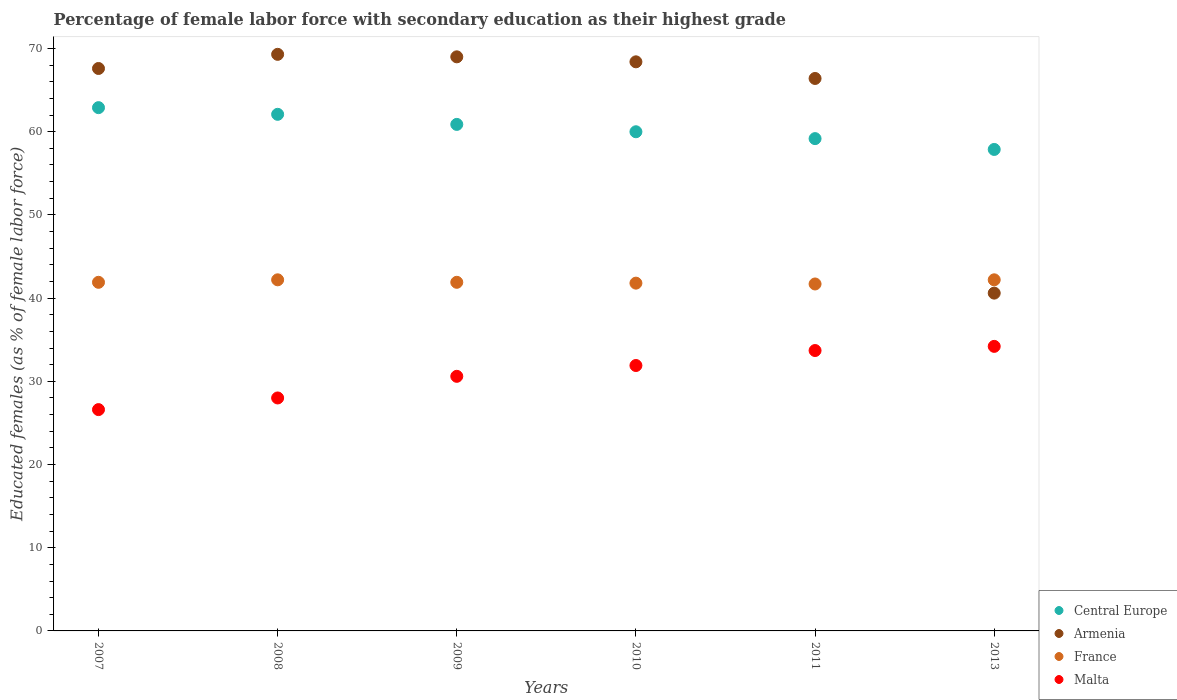Is the number of dotlines equal to the number of legend labels?
Your response must be concise. Yes. What is the percentage of female labor force with secondary education in Armenia in 2008?
Offer a very short reply. 69.3. Across all years, what is the maximum percentage of female labor force with secondary education in France?
Offer a terse response. 42.2. Across all years, what is the minimum percentage of female labor force with secondary education in France?
Make the answer very short. 41.7. In which year was the percentage of female labor force with secondary education in Armenia minimum?
Provide a short and direct response. 2013. What is the total percentage of female labor force with secondary education in Central Europe in the graph?
Your answer should be compact. 362.9. What is the difference between the percentage of female labor force with secondary education in France in 2010 and that in 2011?
Provide a short and direct response. 0.1. What is the difference between the percentage of female labor force with secondary education in Central Europe in 2008 and the percentage of female labor force with secondary education in Malta in 2009?
Offer a terse response. 31.49. What is the average percentage of female labor force with secondary education in Central Europe per year?
Provide a succinct answer. 60.48. In how many years, is the percentage of female labor force with secondary education in Armenia greater than 26 %?
Your answer should be compact. 6. What is the ratio of the percentage of female labor force with secondary education in Armenia in 2007 to that in 2010?
Give a very brief answer. 0.99. Is the difference between the percentage of female labor force with secondary education in France in 2011 and 2013 greater than the difference between the percentage of female labor force with secondary education in Malta in 2011 and 2013?
Offer a terse response. No. What is the difference between the highest and the second highest percentage of female labor force with secondary education in Malta?
Give a very brief answer. 0.5. What is the difference between the highest and the lowest percentage of female labor force with secondary education in Malta?
Your answer should be compact. 7.6. Is it the case that in every year, the sum of the percentage of female labor force with secondary education in France and percentage of female labor force with secondary education in Central Europe  is greater than the sum of percentage of female labor force with secondary education in Armenia and percentage of female labor force with secondary education in Malta?
Your answer should be very brief. Yes. Is it the case that in every year, the sum of the percentage of female labor force with secondary education in Central Europe and percentage of female labor force with secondary education in France  is greater than the percentage of female labor force with secondary education in Malta?
Keep it short and to the point. Yes. How many years are there in the graph?
Your answer should be very brief. 6. Does the graph contain grids?
Keep it short and to the point. No. Where does the legend appear in the graph?
Your answer should be compact. Bottom right. What is the title of the graph?
Your answer should be compact. Percentage of female labor force with secondary education as their highest grade. Does "High income" appear as one of the legend labels in the graph?
Your answer should be very brief. No. What is the label or title of the Y-axis?
Your answer should be very brief. Educated females (as % of female labor force). What is the Educated females (as % of female labor force) of Central Europe in 2007?
Your response must be concise. 62.89. What is the Educated females (as % of female labor force) of Armenia in 2007?
Keep it short and to the point. 67.6. What is the Educated females (as % of female labor force) of France in 2007?
Ensure brevity in your answer.  41.9. What is the Educated females (as % of female labor force) in Malta in 2007?
Offer a terse response. 26.6. What is the Educated females (as % of female labor force) in Central Europe in 2008?
Your answer should be very brief. 62.09. What is the Educated females (as % of female labor force) in Armenia in 2008?
Make the answer very short. 69.3. What is the Educated females (as % of female labor force) of France in 2008?
Provide a short and direct response. 42.2. What is the Educated females (as % of female labor force) of Central Europe in 2009?
Keep it short and to the point. 60.88. What is the Educated females (as % of female labor force) of Armenia in 2009?
Provide a short and direct response. 69. What is the Educated females (as % of female labor force) in France in 2009?
Provide a succinct answer. 41.9. What is the Educated females (as % of female labor force) in Malta in 2009?
Ensure brevity in your answer.  30.6. What is the Educated females (as % of female labor force) of Central Europe in 2010?
Provide a succinct answer. 59.99. What is the Educated females (as % of female labor force) in Armenia in 2010?
Provide a short and direct response. 68.4. What is the Educated females (as % of female labor force) of France in 2010?
Provide a short and direct response. 41.8. What is the Educated females (as % of female labor force) in Malta in 2010?
Your answer should be very brief. 31.9. What is the Educated females (as % of female labor force) in Central Europe in 2011?
Make the answer very short. 59.17. What is the Educated females (as % of female labor force) in Armenia in 2011?
Give a very brief answer. 66.4. What is the Educated females (as % of female labor force) in France in 2011?
Provide a short and direct response. 41.7. What is the Educated females (as % of female labor force) of Malta in 2011?
Keep it short and to the point. 33.7. What is the Educated females (as % of female labor force) in Central Europe in 2013?
Offer a very short reply. 57.87. What is the Educated females (as % of female labor force) in Armenia in 2013?
Ensure brevity in your answer.  40.6. What is the Educated females (as % of female labor force) of France in 2013?
Provide a short and direct response. 42.2. What is the Educated females (as % of female labor force) in Malta in 2013?
Provide a short and direct response. 34.2. Across all years, what is the maximum Educated females (as % of female labor force) of Central Europe?
Your answer should be compact. 62.89. Across all years, what is the maximum Educated females (as % of female labor force) in Armenia?
Offer a very short reply. 69.3. Across all years, what is the maximum Educated females (as % of female labor force) in France?
Provide a short and direct response. 42.2. Across all years, what is the maximum Educated females (as % of female labor force) in Malta?
Keep it short and to the point. 34.2. Across all years, what is the minimum Educated females (as % of female labor force) of Central Europe?
Provide a succinct answer. 57.87. Across all years, what is the minimum Educated females (as % of female labor force) in Armenia?
Provide a short and direct response. 40.6. Across all years, what is the minimum Educated females (as % of female labor force) of France?
Offer a terse response. 41.7. Across all years, what is the minimum Educated females (as % of female labor force) in Malta?
Give a very brief answer. 26.6. What is the total Educated females (as % of female labor force) in Central Europe in the graph?
Keep it short and to the point. 362.9. What is the total Educated females (as % of female labor force) of Armenia in the graph?
Offer a terse response. 381.3. What is the total Educated females (as % of female labor force) of France in the graph?
Offer a very short reply. 251.7. What is the total Educated females (as % of female labor force) in Malta in the graph?
Your response must be concise. 185. What is the difference between the Educated females (as % of female labor force) in Central Europe in 2007 and that in 2008?
Ensure brevity in your answer.  0.8. What is the difference between the Educated females (as % of female labor force) in France in 2007 and that in 2008?
Your answer should be very brief. -0.3. What is the difference between the Educated females (as % of female labor force) of Central Europe in 2007 and that in 2009?
Provide a short and direct response. 2.01. What is the difference between the Educated females (as % of female labor force) in France in 2007 and that in 2009?
Give a very brief answer. 0. What is the difference between the Educated females (as % of female labor force) of Central Europe in 2007 and that in 2010?
Your answer should be very brief. 2.9. What is the difference between the Educated females (as % of female labor force) in Central Europe in 2007 and that in 2011?
Provide a short and direct response. 3.72. What is the difference between the Educated females (as % of female labor force) of Armenia in 2007 and that in 2011?
Your response must be concise. 1.2. What is the difference between the Educated females (as % of female labor force) in France in 2007 and that in 2011?
Provide a succinct answer. 0.2. What is the difference between the Educated females (as % of female labor force) of Malta in 2007 and that in 2011?
Make the answer very short. -7.1. What is the difference between the Educated females (as % of female labor force) in Central Europe in 2007 and that in 2013?
Your answer should be compact. 5.02. What is the difference between the Educated females (as % of female labor force) of Armenia in 2007 and that in 2013?
Your answer should be very brief. 27. What is the difference between the Educated females (as % of female labor force) of Central Europe in 2008 and that in 2009?
Your response must be concise. 1.21. What is the difference between the Educated females (as % of female labor force) of Armenia in 2008 and that in 2009?
Keep it short and to the point. 0.3. What is the difference between the Educated females (as % of female labor force) of Malta in 2008 and that in 2009?
Make the answer very short. -2.6. What is the difference between the Educated females (as % of female labor force) of Central Europe in 2008 and that in 2010?
Keep it short and to the point. 2.1. What is the difference between the Educated females (as % of female labor force) in France in 2008 and that in 2010?
Provide a succinct answer. 0.4. What is the difference between the Educated females (as % of female labor force) in Central Europe in 2008 and that in 2011?
Give a very brief answer. 2.92. What is the difference between the Educated females (as % of female labor force) in Armenia in 2008 and that in 2011?
Your answer should be very brief. 2.9. What is the difference between the Educated females (as % of female labor force) in France in 2008 and that in 2011?
Give a very brief answer. 0.5. What is the difference between the Educated females (as % of female labor force) in Central Europe in 2008 and that in 2013?
Your response must be concise. 4.22. What is the difference between the Educated females (as % of female labor force) in Armenia in 2008 and that in 2013?
Offer a very short reply. 28.7. What is the difference between the Educated females (as % of female labor force) in France in 2008 and that in 2013?
Your answer should be very brief. 0. What is the difference between the Educated females (as % of female labor force) in Central Europe in 2009 and that in 2010?
Keep it short and to the point. 0.88. What is the difference between the Educated females (as % of female labor force) in France in 2009 and that in 2010?
Keep it short and to the point. 0.1. What is the difference between the Educated females (as % of female labor force) of Malta in 2009 and that in 2010?
Provide a short and direct response. -1.3. What is the difference between the Educated females (as % of female labor force) of Central Europe in 2009 and that in 2011?
Your answer should be compact. 1.71. What is the difference between the Educated females (as % of female labor force) in Armenia in 2009 and that in 2011?
Ensure brevity in your answer.  2.6. What is the difference between the Educated females (as % of female labor force) of Central Europe in 2009 and that in 2013?
Keep it short and to the point. 3.01. What is the difference between the Educated females (as % of female labor force) in Armenia in 2009 and that in 2013?
Offer a terse response. 28.4. What is the difference between the Educated females (as % of female labor force) in Central Europe in 2010 and that in 2011?
Offer a very short reply. 0.82. What is the difference between the Educated females (as % of female labor force) of Armenia in 2010 and that in 2011?
Your response must be concise. 2. What is the difference between the Educated females (as % of female labor force) of Malta in 2010 and that in 2011?
Provide a short and direct response. -1.8. What is the difference between the Educated females (as % of female labor force) in Central Europe in 2010 and that in 2013?
Give a very brief answer. 2.13. What is the difference between the Educated females (as % of female labor force) of Armenia in 2010 and that in 2013?
Offer a very short reply. 27.8. What is the difference between the Educated females (as % of female labor force) in Central Europe in 2011 and that in 2013?
Your answer should be compact. 1.3. What is the difference between the Educated females (as % of female labor force) of Armenia in 2011 and that in 2013?
Provide a succinct answer. 25.8. What is the difference between the Educated females (as % of female labor force) in Malta in 2011 and that in 2013?
Provide a succinct answer. -0.5. What is the difference between the Educated females (as % of female labor force) of Central Europe in 2007 and the Educated females (as % of female labor force) of Armenia in 2008?
Ensure brevity in your answer.  -6.41. What is the difference between the Educated females (as % of female labor force) in Central Europe in 2007 and the Educated females (as % of female labor force) in France in 2008?
Give a very brief answer. 20.69. What is the difference between the Educated females (as % of female labor force) of Central Europe in 2007 and the Educated females (as % of female labor force) of Malta in 2008?
Your answer should be compact. 34.89. What is the difference between the Educated females (as % of female labor force) in Armenia in 2007 and the Educated females (as % of female labor force) in France in 2008?
Your response must be concise. 25.4. What is the difference between the Educated females (as % of female labor force) in Armenia in 2007 and the Educated females (as % of female labor force) in Malta in 2008?
Make the answer very short. 39.6. What is the difference between the Educated females (as % of female labor force) in Central Europe in 2007 and the Educated females (as % of female labor force) in Armenia in 2009?
Your response must be concise. -6.11. What is the difference between the Educated females (as % of female labor force) of Central Europe in 2007 and the Educated females (as % of female labor force) of France in 2009?
Provide a succinct answer. 20.99. What is the difference between the Educated females (as % of female labor force) of Central Europe in 2007 and the Educated females (as % of female labor force) of Malta in 2009?
Provide a short and direct response. 32.29. What is the difference between the Educated females (as % of female labor force) in Armenia in 2007 and the Educated females (as % of female labor force) in France in 2009?
Provide a succinct answer. 25.7. What is the difference between the Educated females (as % of female labor force) of Central Europe in 2007 and the Educated females (as % of female labor force) of Armenia in 2010?
Provide a short and direct response. -5.51. What is the difference between the Educated females (as % of female labor force) of Central Europe in 2007 and the Educated females (as % of female labor force) of France in 2010?
Your answer should be compact. 21.09. What is the difference between the Educated females (as % of female labor force) of Central Europe in 2007 and the Educated females (as % of female labor force) of Malta in 2010?
Make the answer very short. 30.99. What is the difference between the Educated females (as % of female labor force) in Armenia in 2007 and the Educated females (as % of female labor force) in France in 2010?
Keep it short and to the point. 25.8. What is the difference between the Educated females (as % of female labor force) of Armenia in 2007 and the Educated females (as % of female labor force) of Malta in 2010?
Your response must be concise. 35.7. What is the difference between the Educated females (as % of female labor force) in Central Europe in 2007 and the Educated females (as % of female labor force) in Armenia in 2011?
Keep it short and to the point. -3.51. What is the difference between the Educated females (as % of female labor force) in Central Europe in 2007 and the Educated females (as % of female labor force) in France in 2011?
Your answer should be very brief. 21.19. What is the difference between the Educated females (as % of female labor force) of Central Europe in 2007 and the Educated females (as % of female labor force) of Malta in 2011?
Offer a terse response. 29.19. What is the difference between the Educated females (as % of female labor force) in Armenia in 2007 and the Educated females (as % of female labor force) in France in 2011?
Give a very brief answer. 25.9. What is the difference between the Educated females (as % of female labor force) in Armenia in 2007 and the Educated females (as % of female labor force) in Malta in 2011?
Offer a terse response. 33.9. What is the difference between the Educated females (as % of female labor force) of Central Europe in 2007 and the Educated females (as % of female labor force) of Armenia in 2013?
Ensure brevity in your answer.  22.29. What is the difference between the Educated females (as % of female labor force) of Central Europe in 2007 and the Educated females (as % of female labor force) of France in 2013?
Give a very brief answer. 20.69. What is the difference between the Educated females (as % of female labor force) in Central Europe in 2007 and the Educated females (as % of female labor force) in Malta in 2013?
Offer a terse response. 28.69. What is the difference between the Educated females (as % of female labor force) of Armenia in 2007 and the Educated females (as % of female labor force) of France in 2013?
Give a very brief answer. 25.4. What is the difference between the Educated females (as % of female labor force) in Armenia in 2007 and the Educated females (as % of female labor force) in Malta in 2013?
Your response must be concise. 33.4. What is the difference between the Educated females (as % of female labor force) of France in 2007 and the Educated females (as % of female labor force) of Malta in 2013?
Your response must be concise. 7.7. What is the difference between the Educated females (as % of female labor force) of Central Europe in 2008 and the Educated females (as % of female labor force) of Armenia in 2009?
Your response must be concise. -6.91. What is the difference between the Educated females (as % of female labor force) in Central Europe in 2008 and the Educated females (as % of female labor force) in France in 2009?
Your answer should be compact. 20.19. What is the difference between the Educated females (as % of female labor force) of Central Europe in 2008 and the Educated females (as % of female labor force) of Malta in 2009?
Give a very brief answer. 31.49. What is the difference between the Educated females (as % of female labor force) of Armenia in 2008 and the Educated females (as % of female labor force) of France in 2009?
Ensure brevity in your answer.  27.4. What is the difference between the Educated females (as % of female labor force) of Armenia in 2008 and the Educated females (as % of female labor force) of Malta in 2009?
Provide a short and direct response. 38.7. What is the difference between the Educated females (as % of female labor force) in Central Europe in 2008 and the Educated females (as % of female labor force) in Armenia in 2010?
Provide a succinct answer. -6.31. What is the difference between the Educated females (as % of female labor force) of Central Europe in 2008 and the Educated females (as % of female labor force) of France in 2010?
Give a very brief answer. 20.29. What is the difference between the Educated females (as % of female labor force) in Central Europe in 2008 and the Educated females (as % of female labor force) in Malta in 2010?
Your response must be concise. 30.19. What is the difference between the Educated females (as % of female labor force) of Armenia in 2008 and the Educated females (as % of female labor force) of France in 2010?
Make the answer very short. 27.5. What is the difference between the Educated females (as % of female labor force) of Armenia in 2008 and the Educated females (as % of female labor force) of Malta in 2010?
Ensure brevity in your answer.  37.4. What is the difference between the Educated females (as % of female labor force) of Central Europe in 2008 and the Educated females (as % of female labor force) of Armenia in 2011?
Ensure brevity in your answer.  -4.31. What is the difference between the Educated females (as % of female labor force) of Central Europe in 2008 and the Educated females (as % of female labor force) of France in 2011?
Offer a terse response. 20.39. What is the difference between the Educated females (as % of female labor force) of Central Europe in 2008 and the Educated females (as % of female labor force) of Malta in 2011?
Your answer should be compact. 28.39. What is the difference between the Educated females (as % of female labor force) in Armenia in 2008 and the Educated females (as % of female labor force) in France in 2011?
Provide a succinct answer. 27.6. What is the difference between the Educated females (as % of female labor force) of Armenia in 2008 and the Educated females (as % of female labor force) of Malta in 2011?
Your answer should be very brief. 35.6. What is the difference between the Educated females (as % of female labor force) of France in 2008 and the Educated females (as % of female labor force) of Malta in 2011?
Provide a short and direct response. 8.5. What is the difference between the Educated females (as % of female labor force) in Central Europe in 2008 and the Educated females (as % of female labor force) in Armenia in 2013?
Your answer should be very brief. 21.49. What is the difference between the Educated females (as % of female labor force) in Central Europe in 2008 and the Educated females (as % of female labor force) in France in 2013?
Offer a terse response. 19.89. What is the difference between the Educated females (as % of female labor force) in Central Europe in 2008 and the Educated females (as % of female labor force) in Malta in 2013?
Make the answer very short. 27.89. What is the difference between the Educated females (as % of female labor force) of Armenia in 2008 and the Educated females (as % of female labor force) of France in 2013?
Your answer should be compact. 27.1. What is the difference between the Educated females (as % of female labor force) in Armenia in 2008 and the Educated females (as % of female labor force) in Malta in 2013?
Give a very brief answer. 35.1. What is the difference between the Educated females (as % of female labor force) in Central Europe in 2009 and the Educated females (as % of female labor force) in Armenia in 2010?
Ensure brevity in your answer.  -7.52. What is the difference between the Educated females (as % of female labor force) in Central Europe in 2009 and the Educated females (as % of female labor force) in France in 2010?
Ensure brevity in your answer.  19.08. What is the difference between the Educated females (as % of female labor force) of Central Europe in 2009 and the Educated females (as % of female labor force) of Malta in 2010?
Keep it short and to the point. 28.98. What is the difference between the Educated females (as % of female labor force) in Armenia in 2009 and the Educated females (as % of female labor force) in France in 2010?
Your response must be concise. 27.2. What is the difference between the Educated females (as % of female labor force) in Armenia in 2009 and the Educated females (as % of female labor force) in Malta in 2010?
Offer a terse response. 37.1. What is the difference between the Educated females (as % of female labor force) in Central Europe in 2009 and the Educated females (as % of female labor force) in Armenia in 2011?
Ensure brevity in your answer.  -5.52. What is the difference between the Educated females (as % of female labor force) of Central Europe in 2009 and the Educated females (as % of female labor force) of France in 2011?
Provide a succinct answer. 19.18. What is the difference between the Educated females (as % of female labor force) of Central Europe in 2009 and the Educated females (as % of female labor force) of Malta in 2011?
Offer a very short reply. 27.18. What is the difference between the Educated females (as % of female labor force) in Armenia in 2009 and the Educated females (as % of female labor force) in France in 2011?
Keep it short and to the point. 27.3. What is the difference between the Educated females (as % of female labor force) of Armenia in 2009 and the Educated females (as % of female labor force) of Malta in 2011?
Keep it short and to the point. 35.3. What is the difference between the Educated females (as % of female labor force) in France in 2009 and the Educated females (as % of female labor force) in Malta in 2011?
Offer a terse response. 8.2. What is the difference between the Educated females (as % of female labor force) in Central Europe in 2009 and the Educated females (as % of female labor force) in Armenia in 2013?
Provide a short and direct response. 20.28. What is the difference between the Educated females (as % of female labor force) of Central Europe in 2009 and the Educated females (as % of female labor force) of France in 2013?
Your answer should be very brief. 18.68. What is the difference between the Educated females (as % of female labor force) in Central Europe in 2009 and the Educated females (as % of female labor force) in Malta in 2013?
Provide a short and direct response. 26.68. What is the difference between the Educated females (as % of female labor force) of Armenia in 2009 and the Educated females (as % of female labor force) of France in 2013?
Provide a succinct answer. 26.8. What is the difference between the Educated females (as % of female labor force) in Armenia in 2009 and the Educated females (as % of female labor force) in Malta in 2013?
Make the answer very short. 34.8. What is the difference between the Educated females (as % of female labor force) in Central Europe in 2010 and the Educated females (as % of female labor force) in Armenia in 2011?
Offer a very short reply. -6.41. What is the difference between the Educated females (as % of female labor force) of Central Europe in 2010 and the Educated females (as % of female labor force) of France in 2011?
Keep it short and to the point. 18.29. What is the difference between the Educated females (as % of female labor force) in Central Europe in 2010 and the Educated females (as % of female labor force) in Malta in 2011?
Provide a succinct answer. 26.29. What is the difference between the Educated females (as % of female labor force) in Armenia in 2010 and the Educated females (as % of female labor force) in France in 2011?
Your response must be concise. 26.7. What is the difference between the Educated females (as % of female labor force) of Armenia in 2010 and the Educated females (as % of female labor force) of Malta in 2011?
Your answer should be compact. 34.7. What is the difference between the Educated females (as % of female labor force) of Central Europe in 2010 and the Educated females (as % of female labor force) of Armenia in 2013?
Keep it short and to the point. 19.39. What is the difference between the Educated females (as % of female labor force) in Central Europe in 2010 and the Educated females (as % of female labor force) in France in 2013?
Ensure brevity in your answer.  17.79. What is the difference between the Educated females (as % of female labor force) in Central Europe in 2010 and the Educated females (as % of female labor force) in Malta in 2013?
Offer a very short reply. 25.79. What is the difference between the Educated females (as % of female labor force) in Armenia in 2010 and the Educated females (as % of female labor force) in France in 2013?
Offer a very short reply. 26.2. What is the difference between the Educated females (as % of female labor force) in Armenia in 2010 and the Educated females (as % of female labor force) in Malta in 2013?
Offer a very short reply. 34.2. What is the difference between the Educated females (as % of female labor force) in Central Europe in 2011 and the Educated females (as % of female labor force) in Armenia in 2013?
Keep it short and to the point. 18.57. What is the difference between the Educated females (as % of female labor force) in Central Europe in 2011 and the Educated females (as % of female labor force) in France in 2013?
Your answer should be very brief. 16.97. What is the difference between the Educated females (as % of female labor force) of Central Europe in 2011 and the Educated females (as % of female labor force) of Malta in 2013?
Keep it short and to the point. 24.97. What is the difference between the Educated females (as % of female labor force) in Armenia in 2011 and the Educated females (as % of female labor force) in France in 2013?
Ensure brevity in your answer.  24.2. What is the difference between the Educated females (as % of female labor force) in Armenia in 2011 and the Educated females (as % of female labor force) in Malta in 2013?
Make the answer very short. 32.2. What is the difference between the Educated females (as % of female labor force) of France in 2011 and the Educated females (as % of female labor force) of Malta in 2013?
Offer a terse response. 7.5. What is the average Educated females (as % of female labor force) of Central Europe per year?
Give a very brief answer. 60.48. What is the average Educated females (as % of female labor force) of Armenia per year?
Offer a very short reply. 63.55. What is the average Educated females (as % of female labor force) of France per year?
Offer a very short reply. 41.95. What is the average Educated females (as % of female labor force) in Malta per year?
Provide a succinct answer. 30.83. In the year 2007, what is the difference between the Educated females (as % of female labor force) of Central Europe and Educated females (as % of female labor force) of Armenia?
Provide a succinct answer. -4.71. In the year 2007, what is the difference between the Educated females (as % of female labor force) of Central Europe and Educated females (as % of female labor force) of France?
Ensure brevity in your answer.  20.99. In the year 2007, what is the difference between the Educated females (as % of female labor force) of Central Europe and Educated females (as % of female labor force) of Malta?
Make the answer very short. 36.29. In the year 2007, what is the difference between the Educated females (as % of female labor force) in Armenia and Educated females (as % of female labor force) in France?
Your answer should be very brief. 25.7. In the year 2007, what is the difference between the Educated females (as % of female labor force) in France and Educated females (as % of female labor force) in Malta?
Offer a very short reply. 15.3. In the year 2008, what is the difference between the Educated females (as % of female labor force) in Central Europe and Educated females (as % of female labor force) in Armenia?
Provide a succinct answer. -7.21. In the year 2008, what is the difference between the Educated females (as % of female labor force) in Central Europe and Educated females (as % of female labor force) in France?
Make the answer very short. 19.89. In the year 2008, what is the difference between the Educated females (as % of female labor force) of Central Europe and Educated females (as % of female labor force) of Malta?
Provide a succinct answer. 34.09. In the year 2008, what is the difference between the Educated females (as % of female labor force) of Armenia and Educated females (as % of female labor force) of France?
Give a very brief answer. 27.1. In the year 2008, what is the difference between the Educated females (as % of female labor force) of Armenia and Educated females (as % of female labor force) of Malta?
Give a very brief answer. 41.3. In the year 2008, what is the difference between the Educated females (as % of female labor force) in France and Educated females (as % of female labor force) in Malta?
Offer a terse response. 14.2. In the year 2009, what is the difference between the Educated females (as % of female labor force) in Central Europe and Educated females (as % of female labor force) in Armenia?
Your answer should be compact. -8.12. In the year 2009, what is the difference between the Educated females (as % of female labor force) of Central Europe and Educated females (as % of female labor force) of France?
Give a very brief answer. 18.98. In the year 2009, what is the difference between the Educated females (as % of female labor force) of Central Europe and Educated females (as % of female labor force) of Malta?
Ensure brevity in your answer.  30.28. In the year 2009, what is the difference between the Educated females (as % of female labor force) in Armenia and Educated females (as % of female labor force) in France?
Give a very brief answer. 27.1. In the year 2009, what is the difference between the Educated females (as % of female labor force) of Armenia and Educated females (as % of female labor force) of Malta?
Offer a terse response. 38.4. In the year 2009, what is the difference between the Educated females (as % of female labor force) of France and Educated females (as % of female labor force) of Malta?
Offer a very short reply. 11.3. In the year 2010, what is the difference between the Educated females (as % of female labor force) in Central Europe and Educated females (as % of female labor force) in Armenia?
Your answer should be compact. -8.41. In the year 2010, what is the difference between the Educated females (as % of female labor force) of Central Europe and Educated females (as % of female labor force) of France?
Offer a terse response. 18.19. In the year 2010, what is the difference between the Educated females (as % of female labor force) in Central Europe and Educated females (as % of female labor force) in Malta?
Give a very brief answer. 28.09. In the year 2010, what is the difference between the Educated females (as % of female labor force) in Armenia and Educated females (as % of female labor force) in France?
Ensure brevity in your answer.  26.6. In the year 2010, what is the difference between the Educated females (as % of female labor force) of Armenia and Educated females (as % of female labor force) of Malta?
Your response must be concise. 36.5. In the year 2010, what is the difference between the Educated females (as % of female labor force) of France and Educated females (as % of female labor force) of Malta?
Keep it short and to the point. 9.9. In the year 2011, what is the difference between the Educated females (as % of female labor force) in Central Europe and Educated females (as % of female labor force) in Armenia?
Your answer should be very brief. -7.23. In the year 2011, what is the difference between the Educated females (as % of female labor force) in Central Europe and Educated females (as % of female labor force) in France?
Your response must be concise. 17.47. In the year 2011, what is the difference between the Educated females (as % of female labor force) of Central Europe and Educated females (as % of female labor force) of Malta?
Make the answer very short. 25.47. In the year 2011, what is the difference between the Educated females (as % of female labor force) of Armenia and Educated females (as % of female labor force) of France?
Your answer should be compact. 24.7. In the year 2011, what is the difference between the Educated females (as % of female labor force) of Armenia and Educated females (as % of female labor force) of Malta?
Provide a succinct answer. 32.7. In the year 2013, what is the difference between the Educated females (as % of female labor force) in Central Europe and Educated females (as % of female labor force) in Armenia?
Your answer should be very brief. 17.27. In the year 2013, what is the difference between the Educated females (as % of female labor force) of Central Europe and Educated females (as % of female labor force) of France?
Your answer should be compact. 15.67. In the year 2013, what is the difference between the Educated females (as % of female labor force) in Central Europe and Educated females (as % of female labor force) in Malta?
Keep it short and to the point. 23.67. In the year 2013, what is the difference between the Educated females (as % of female labor force) in Armenia and Educated females (as % of female labor force) in France?
Give a very brief answer. -1.6. In the year 2013, what is the difference between the Educated females (as % of female labor force) in Armenia and Educated females (as % of female labor force) in Malta?
Offer a very short reply. 6.4. In the year 2013, what is the difference between the Educated females (as % of female labor force) in France and Educated females (as % of female labor force) in Malta?
Provide a succinct answer. 8. What is the ratio of the Educated females (as % of female labor force) of Central Europe in 2007 to that in 2008?
Your answer should be compact. 1.01. What is the ratio of the Educated females (as % of female labor force) in Armenia in 2007 to that in 2008?
Offer a very short reply. 0.98. What is the ratio of the Educated females (as % of female labor force) in France in 2007 to that in 2008?
Offer a terse response. 0.99. What is the ratio of the Educated females (as % of female labor force) in Malta in 2007 to that in 2008?
Keep it short and to the point. 0.95. What is the ratio of the Educated females (as % of female labor force) in Central Europe in 2007 to that in 2009?
Your answer should be compact. 1.03. What is the ratio of the Educated females (as % of female labor force) in Armenia in 2007 to that in 2009?
Ensure brevity in your answer.  0.98. What is the ratio of the Educated females (as % of female labor force) of Malta in 2007 to that in 2009?
Make the answer very short. 0.87. What is the ratio of the Educated females (as % of female labor force) of Central Europe in 2007 to that in 2010?
Ensure brevity in your answer.  1.05. What is the ratio of the Educated females (as % of female labor force) in Armenia in 2007 to that in 2010?
Your answer should be compact. 0.99. What is the ratio of the Educated females (as % of female labor force) of France in 2007 to that in 2010?
Ensure brevity in your answer.  1. What is the ratio of the Educated females (as % of female labor force) in Malta in 2007 to that in 2010?
Your answer should be very brief. 0.83. What is the ratio of the Educated females (as % of female labor force) in Central Europe in 2007 to that in 2011?
Provide a short and direct response. 1.06. What is the ratio of the Educated females (as % of female labor force) of Armenia in 2007 to that in 2011?
Your answer should be compact. 1.02. What is the ratio of the Educated females (as % of female labor force) of France in 2007 to that in 2011?
Offer a terse response. 1. What is the ratio of the Educated females (as % of female labor force) in Malta in 2007 to that in 2011?
Offer a very short reply. 0.79. What is the ratio of the Educated females (as % of female labor force) in Central Europe in 2007 to that in 2013?
Your response must be concise. 1.09. What is the ratio of the Educated females (as % of female labor force) of Armenia in 2007 to that in 2013?
Make the answer very short. 1.67. What is the ratio of the Educated females (as % of female labor force) of Malta in 2007 to that in 2013?
Make the answer very short. 0.78. What is the ratio of the Educated females (as % of female labor force) of Central Europe in 2008 to that in 2009?
Provide a succinct answer. 1.02. What is the ratio of the Educated females (as % of female labor force) of Armenia in 2008 to that in 2009?
Offer a terse response. 1. What is the ratio of the Educated females (as % of female labor force) in France in 2008 to that in 2009?
Provide a succinct answer. 1.01. What is the ratio of the Educated females (as % of female labor force) in Malta in 2008 to that in 2009?
Provide a succinct answer. 0.92. What is the ratio of the Educated females (as % of female labor force) of Central Europe in 2008 to that in 2010?
Ensure brevity in your answer.  1.03. What is the ratio of the Educated females (as % of female labor force) in Armenia in 2008 to that in 2010?
Offer a very short reply. 1.01. What is the ratio of the Educated females (as % of female labor force) of France in 2008 to that in 2010?
Your response must be concise. 1.01. What is the ratio of the Educated females (as % of female labor force) of Malta in 2008 to that in 2010?
Ensure brevity in your answer.  0.88. What is the ratio of the Educated females (as % of female labor force) in Central Europe in 2008 to that in 2011?
Provide a succinct answer. 1.05. What is the ratio of the Educated females (as % of female labor force) in Armenia in 2008 to that in 2011?
Your answer should be very brief. 1.04. What is the ratio of the Educated females (as % of female labor force) of Malta in 2008 to that in 2011?
Give a very brief answer. 0.83. What is the ratio of the Educated females (as % of female labor force) of Central Europe in 2008 to that in 2013?
Offer a terse response. 1.07. What is the ratio of the Educated females (as % of female labor force) of Armenia in 2008 to that in 2013?
Your answer should be compact. 1.71. What is the ratio of the Educated females (as % of female labor force) in Malta in 2008 to that in 2013?
Ensure brevity in your answer.  0.82. What is the ratio of the Educated females (as % of female labor force) in Central Europe in 2009 to that in 2010?
Offer a very short reply. 1.01. What is the ratio of the Educated females (as % of female labor force) of Armenia in 2009 to that in 2010?
Provide a succinct answer. 1.01. What is the ratio of the Educated females (as % of female labor force) of France in 2009 to that in 2010?
Give a very brief answer. 1. What is the ratio of the Educated females (as % of female labor force) in Malta in 2009 to that in 2010?
Provide a succinct answer. 0.96. What is the ratio of the Educated females (as % of female labor force) of Central Europe in 2009 to that in 2011?
Offer a terse response. 1.03. What is the ratio of the Educated females (as % of female labor force) of Armenia in 2009 to that in 2011?
Ensure brevity in your answer.  1.04. What is the ratio of the Educated females (as % of female labor force) in France in 2009 to that in 2011?
Provide a succinct answer. 1. What is the ratio of the Educated females (as % of female labor force) of Malta in 2009 to that in 2011?
Offer a very short reply. 0.91. What is the ratio of the Educated females (as % of female labor force) in Central Europe in 2009 to that in 2013?
Give a very brief answer. 1.05. What is the ratio of the Educated females (as % of female labor force) in Armenia in 2009 to that in 2013?
Make the answer very short. 1.7. What is the ratio of the Educated females (as % of female labor force) in Malta in 2009 to that in 2013?
Your answer should be compact. 0.89. What is the ratio of the Educated females (as % of female labor force) of Central Europe in 2010 to that in 2011?
Your answer should be very brief. 1.01. What is the ratio of the Educated females (as % of female labor force) of Armenia in 2010 to that in 2011?
Keep it short and to the point. 1.03. What is the ratio of the Educated females (as % of female labor force) of Malta in 2010 to that in 2011?
Keep it short and to the point. 0.95. What is the ratio of the Educated females (as % of female labor force) in Central Europe in 2010 to that in 2013?
Provide a succinct answer. 1.04. What is the ratio of the Educated females (as % of female labor force) of Armenia in 2010 to that in 2013?
Your response must be concise. 1.68. What is the ratio of the Educated females (as % of female labor force) of Malta in 2010 to that in 2013?
Your answer should be very brief. 0.93. What is the ratio of the Educated females (as % of female labor force) of Central Europe in 2011 to that in 2013?
Keep it short and to the point. 1.02. What is the ratio of the Educated females (as % of female labor force) in Armenia in 2011 to that in 2013?
Your answer should be compact. 1.64. What is the ratio of the Educated females (as % of female labor force) in Malta in 2011 to that in 2013?
Your answer should be very brief. 0.99. What is the difference between the highest and the second highest Educated females (as % of female labor force) in Central Europe?
Make the answer very short. 0.8. What is the difference between the highest and the second highest Educated females (as % of female labor force) of Armenia?
Your answer should be compact. 0.3. What is the difference between the highest and the lowest Educated females (as % of female labor force) of Central Europe?
Offer a very short reply. 5.02. What is the difference between the highest and the lowest Educated females (as % of female labor force) of Armenia?
Provide a short and direct response. 28.7. What is the difference between the highest and the lowest Educated females (as % of female labor force) in Malta?
Your answer should be compact. 7.6. 